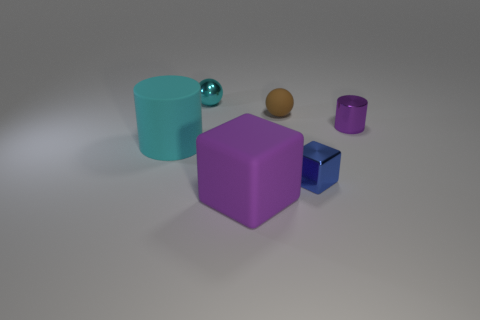Does the blue thing have the same size as the purple metallic thing behind the large block?
Ensure brevity in your answer.  Yes. The small rubber object has what color?
Offer a terse response. Brown. There is a purple object on the left side of the tiny ball on the right side of the small thing that is left of the large purple matte cube; what is its shape?
Give a very brief answer. Cube. There is a purple object behind the big object that is in front of the large cyan cylinder; what is it made of?
Make the answer very short. Metal. There is a tiny thing that is the same material as the big cyan cylinder; what is its shape?
Keep it short and to the point. Sphere. Are there any other things that have the same shape as the cyan metal thing?
Provide a short and direct response. Yes. What number of shiny balls are behind the purple cube?
Provide a succinct answer. 1. Are there any tiny brown rubber blocks?
Your response must be concise. No. The ball in front of the sphere to the left of the tiny sphere that is on the right side of the tiny cyan thing is what color?
Give a very brief answer. Brown. Is there a big cylinder in front of the metal thing that is in front of the tiny purple metallic thing?
Your answer should be compact. No. 